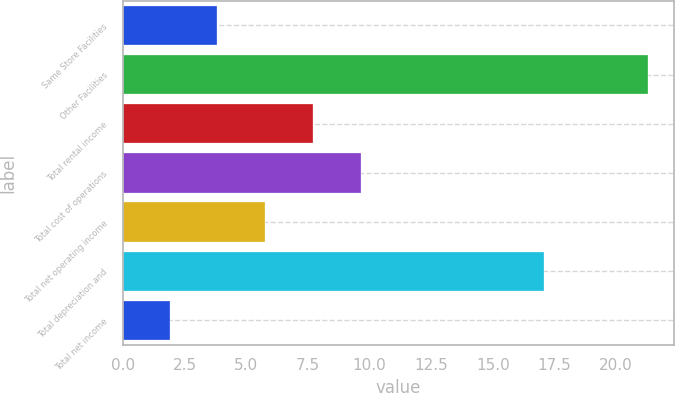Convert chart. <chart><loc_0><loc_0><loc_500><loc_500><bar_chart><fcel>Same Store Facilities<fcel>Other Facilities<fcel>Total rental income<fcel>Total cost of operations<fcel>Total net operating income<fcel>Total depreciation and<fcel>Total net income<nl><fcel>3.84<fcel>21.3<fcel>7.72<fcel>9.66<fcel>5.78<fcel>17.1<fcel>1.9<nl></chart> 